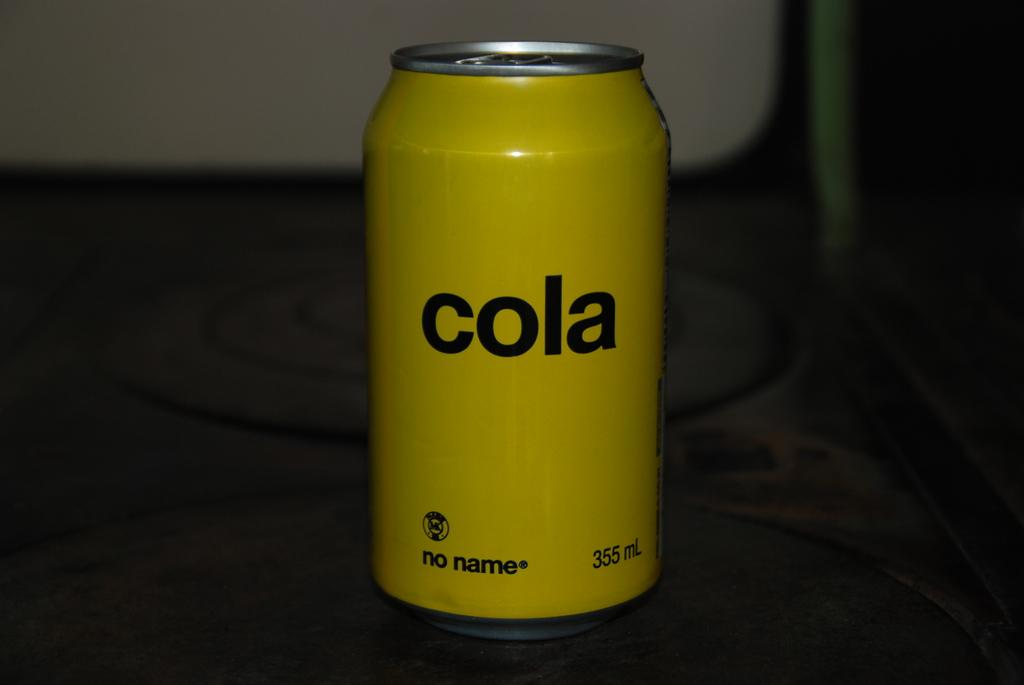<image>
Create a compact narrative representing the image presented. a yellow cola can that is on a dark surface 